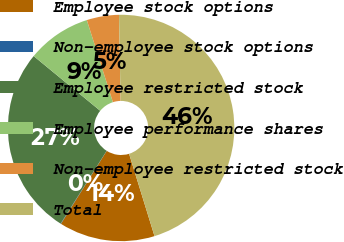Convert chart to OTSL. <chart><loc_0><loc_0><loc_500><loc_500><pie_chart><fcel>Employee stock options<fcel>Non-employee stock options<fcel>Employee restricted stock<fcel>Employee performance shares<fcel>Non-employee restricted stock<fcel>Total<nl><fcel>13.69%<fcel>0.05%<fcel>26.98%<fcel>9.15%<fcel>4.6%<fcel>45.53%<nl></chart> 